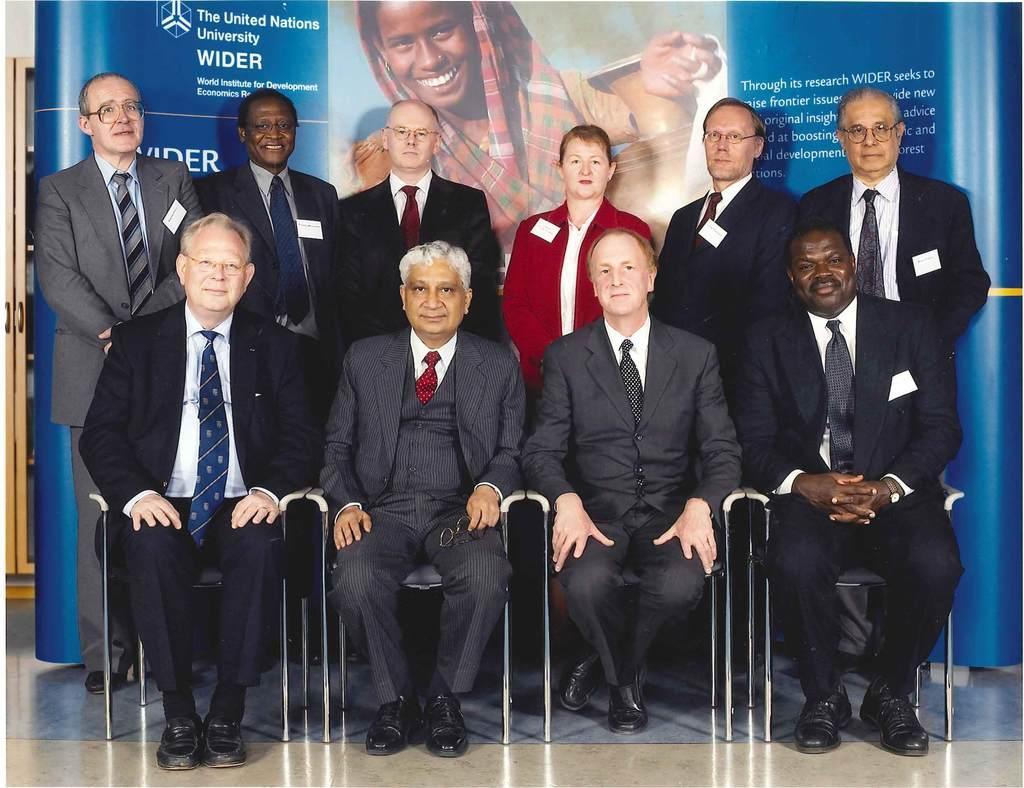Can you describe this image briefly? This image consists of many persons all are wearing suits. There are four persons sitting in the chairs. At the bottom, there is a floor. In the background, there is a banner. To the left, there is a cupboard. 